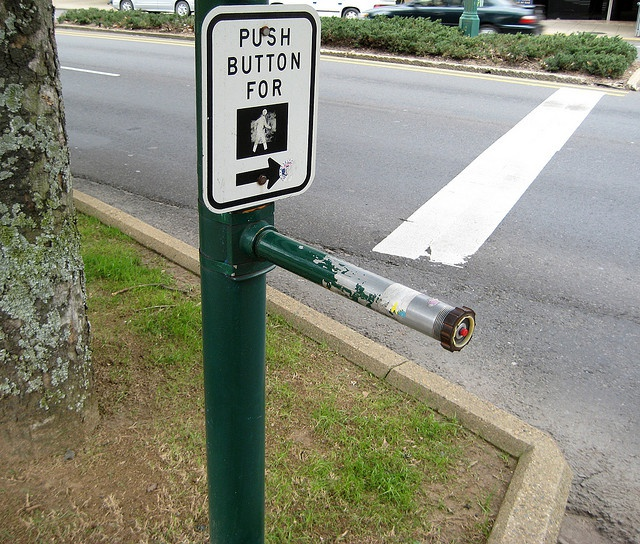Describe the objects in this image and their specific colors. I can see car in black, lightgray, gray, and blue tones, car in black, white, gray, and darkgray tones, and car in black, lightgray, gray, darkgray, and olive tones in this image. 